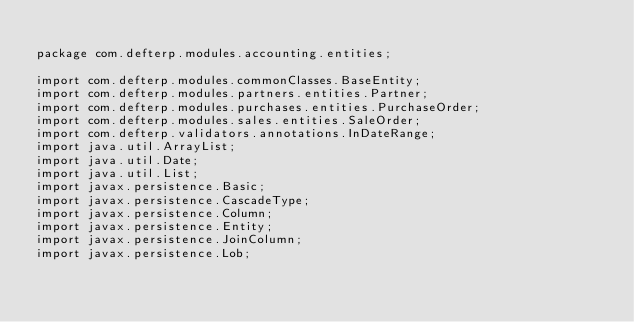<code> <loc_0><loc_0><loc_500><loc_500><_Java_>
package com.defterp.modules.accounting.entities;

import com.defterp.modules.commonClasses.BaseEntity;
import com.defterp.modules.partners.entities.Partner;
import com.defterp.modules.purchases.entities.PurchaseOrder;
import com.defterp.modules.sales.entities.SaleOrder;
import com.defterp.validators.annotations.InDateRange;
import java.util.ArrayList;
import java.util.Date;
import java.util.List;
import javax.persistence.Basic;
import javax.persistence.CascadeType;
import javax.persistence.Column;
import javax.persistence.Entity;
import javax.persistence.JoinColumn;
import javax.persistence.Lob;</code> 